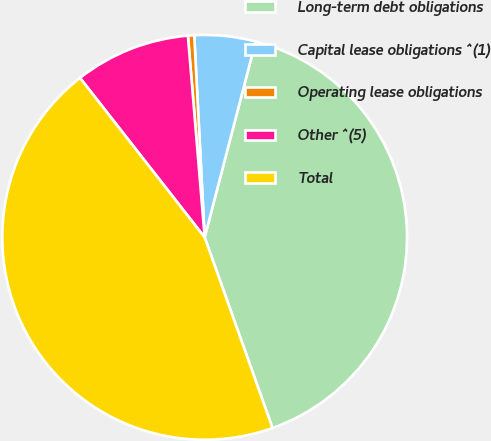Convert chart to OTSL. <chart><loc_0><loc_0><loc_500><loc_500><pie_chart><fcel>Long-term debt obligations<fcel>Capital lease obligations ^(1)<fcel>Operating lease obligations<fcel>Other ^(5)<fcel>Total<nl><fcel>40.51%<fcel>4.87%<fcel>0.5%<fcel>9.24%<fcel>44.88%<nl></chart> 